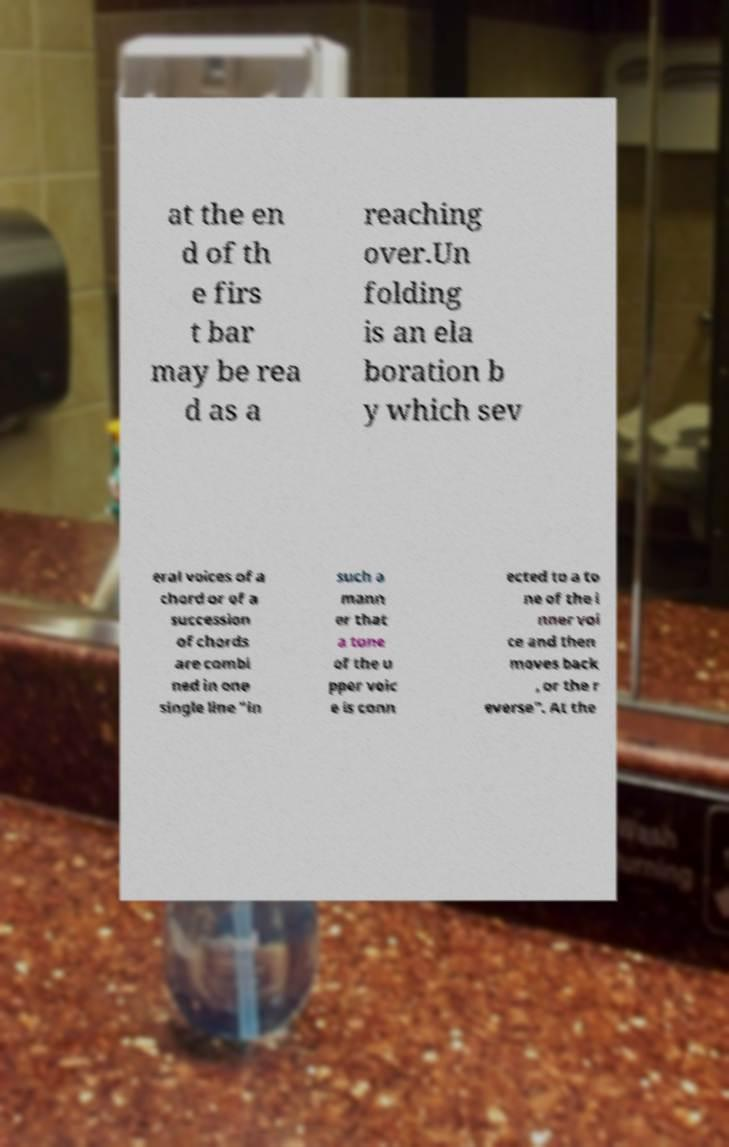Could you extract and type out the text from this image? at the en d of th e firs t bar may be rea d as a reaching over.Un folding is an ela boration b y which sev eral voices of a chord or of a succession of chords are combi ned in one single line "in such a mann er that a tone of the u pper voic e is conn ected to a to ne of the i nner voi ce and then moves back , or the r everse". At the 